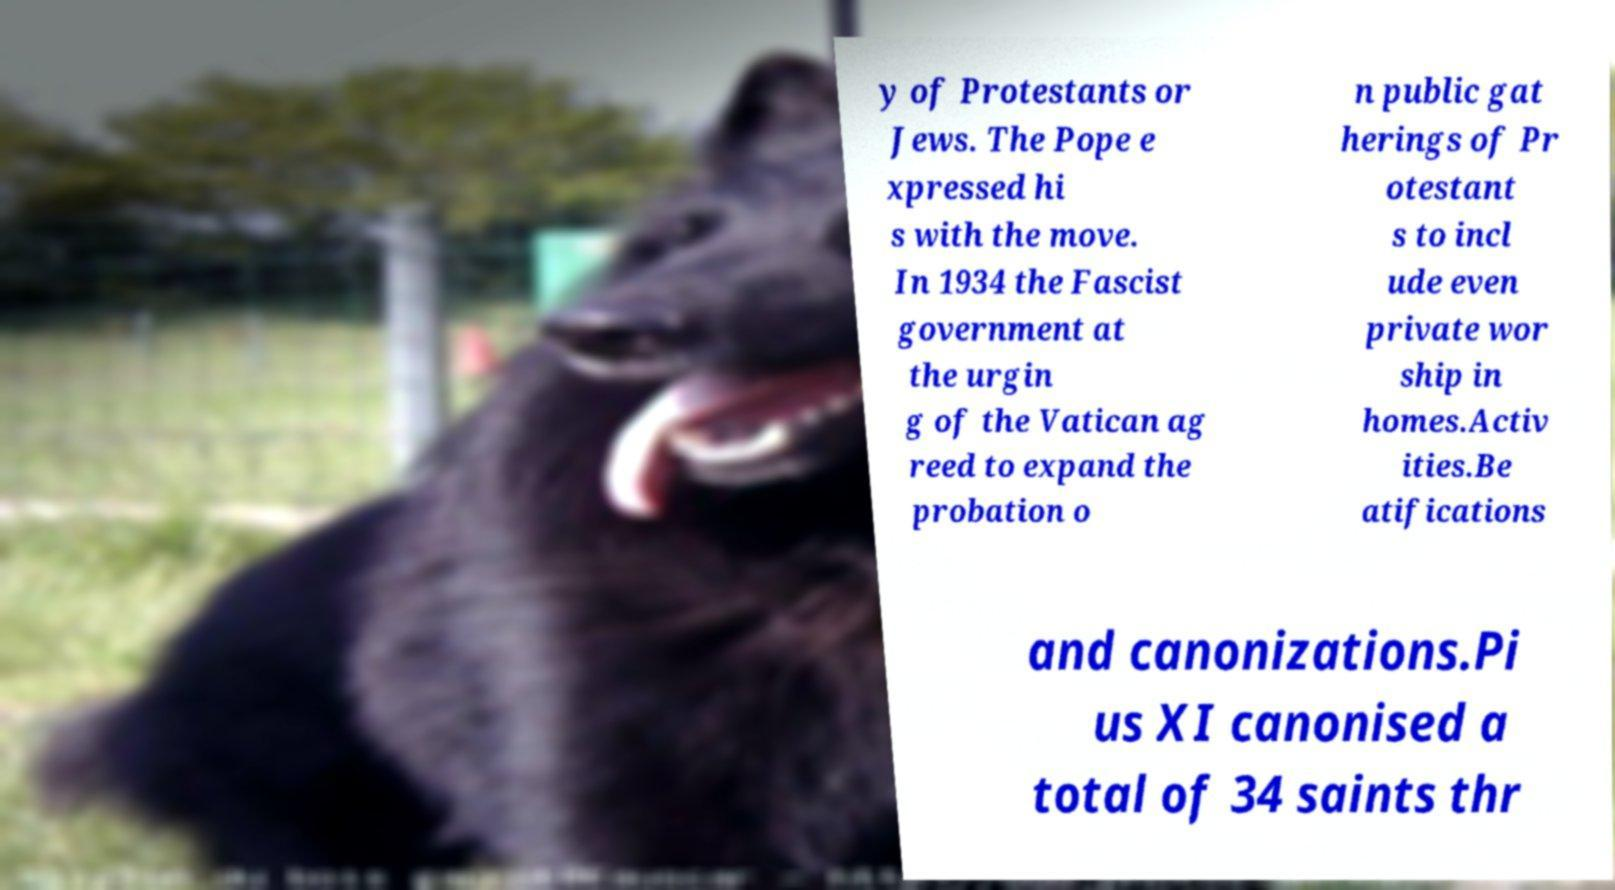Can you read and provide the text displayed in the image?This photo seems to have some interesting text. Can you extract and type it out for me? y of Protestants or Jews. The Pope e xpressed hi s with the move. In 1934 the Fascist government at the urgin g of the Vatican ag reed to expand the probation o n public gat herings of Pr otestant s to incl ude even private wor ship in homes.Activ ities.Be atifications and canonizations.Pi us XI canonised a total of 34 saints thr 